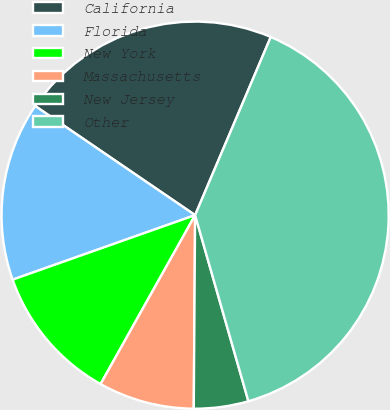Convert chart to OTSL. <chart><loc_0><loc_0><loc_500><loc_500><pie_chart><fcel>California<fcel>Florida<fcel>New York<fcel>Massachusetts<fcel>New Jersey<fcel>Other<nl><fcel>21.86%<fcel>14.94%<fcel>11.47%<fcel>8.01%<fcel>4.55%<fcel>39.17%<nl></chart> 